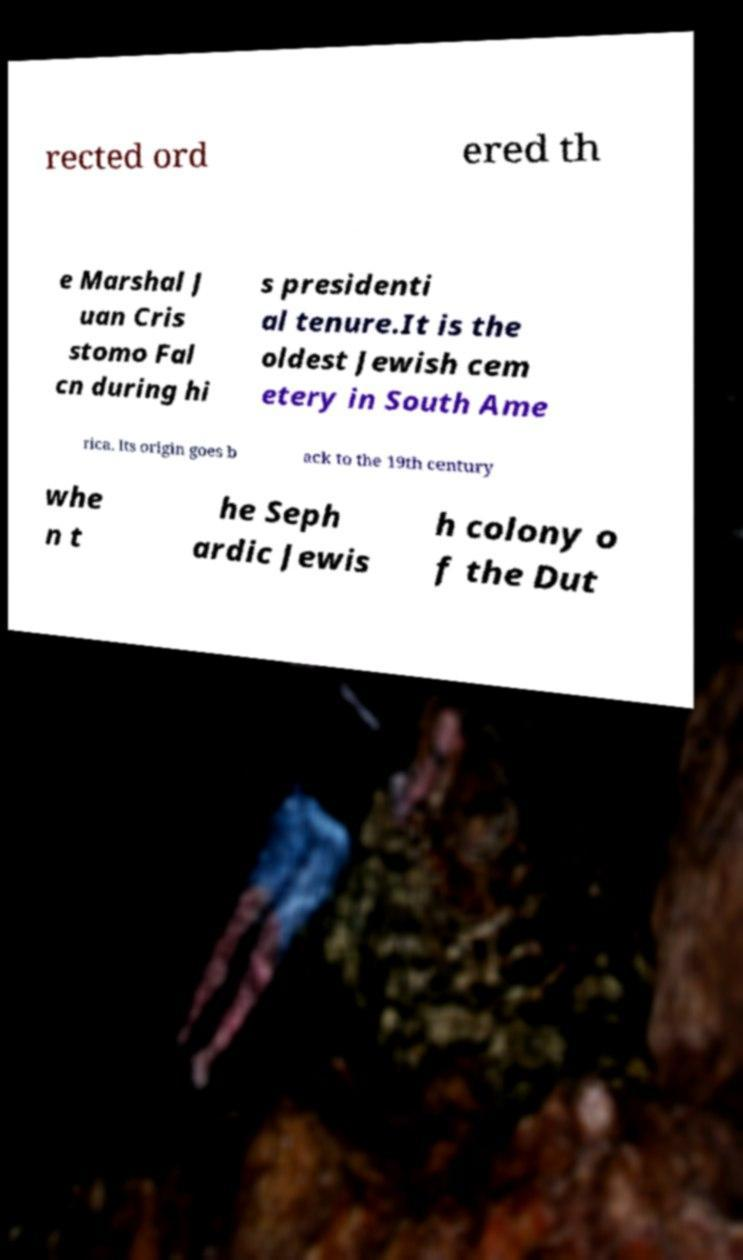For documentation purposes, I need the text within this image transcribed. Could you provide that? rected ord ered th e Marshal J uan Cris stomo Fal cn during hi s presidenti al tenure.It is the oldest Jewish cem etery in South Ame rica. Its origin goes b ack to the 19th century whe n t he Seph ardic Jewis h colony o f the Dut 